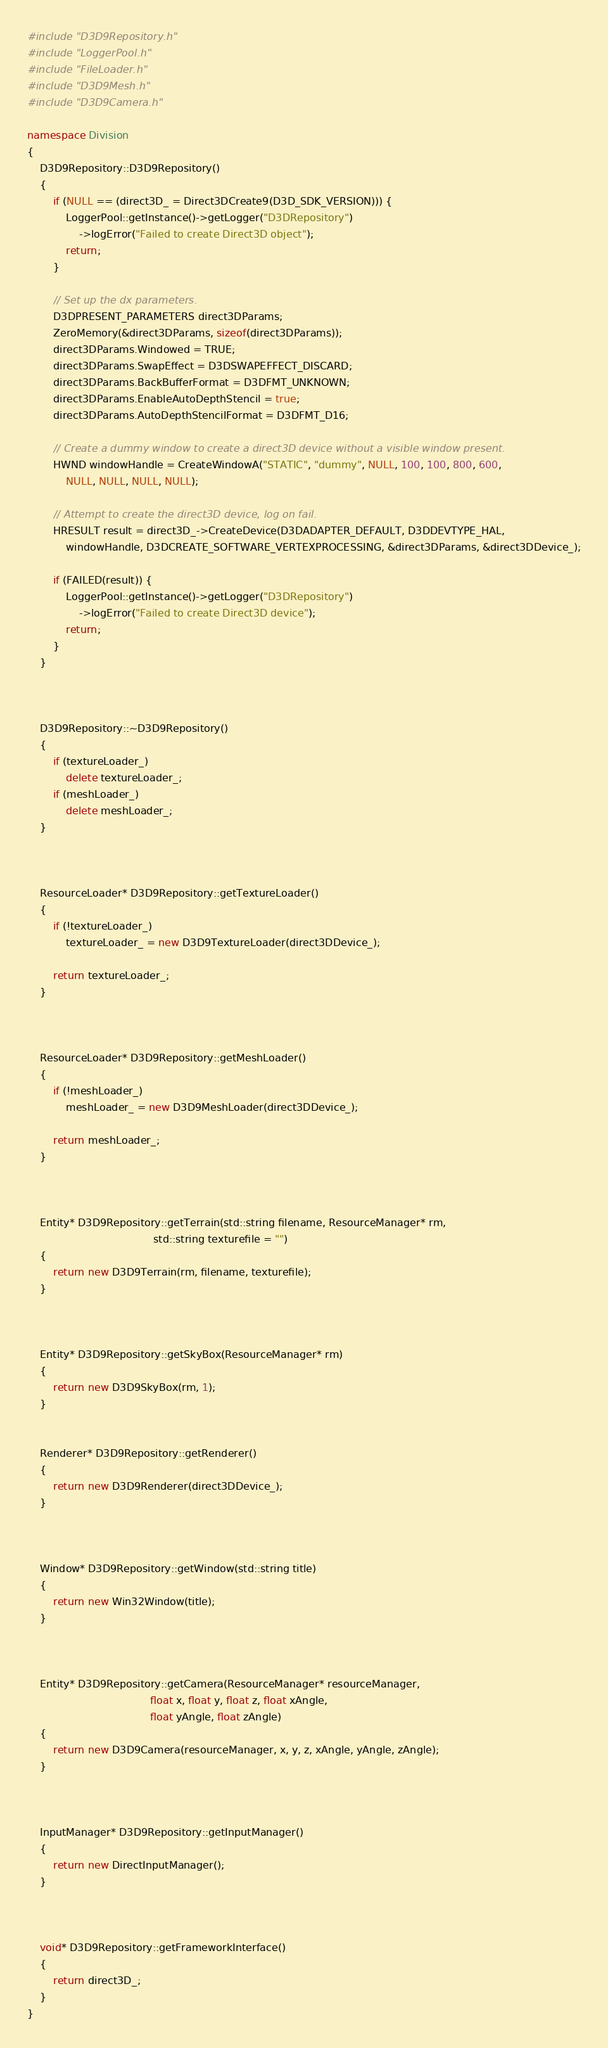<code> <loc_0><loc_0><loc_500><loc_500><_C++_>#include "D3D9Repository.h"
#include "LoggerPool.h"
#include "FileLoader.h"
#include "D3D9Mesh.h"
#include "D3D9Camera.h"

namespace Division
{
	D3D9Repository::D3D9Repository()
	{
		if (NULL == (direct3D_ = Direct3DCreate9(D3D_SDK_VERSION))) {
			LoggerPool::getInstance()->getLogger("D3DRepository")
				->logError("Failed to create Direct3D object");
			return;
		}

		// Set up the dx parameters.
		D3DPRESENT_PARAMETERS direct3DParams;
		ZeroMemory(&direct3DParams, sizeof(direct3DParams));
		direct3DParams.Windowed = TRUE;
		direct3DParams.SwapEffect = D3DSWAPEFFECT_DISCARD;
		direct3DParams.BackBufferFormat = D3DFMT_UNKNOWN;
		direct3DParams.EnableAutoDepthStencil = true;
		direct3DParams.AutoDepthStencilFormat = D3DFMT_D16;

		// Create a dummy window to create a direct3D device without a visible window present.
		HWND windowHandle = CreateWindowA("STATIC", "dummy", NULL, 100, 100, 800, 600,
			NULL, NULL, NULL, NULL);

		// Attempt to create the direct3D device, log on fail.
		HRESULT result = direct3D_->CreateDevice(D3DADAPTER_DEFAULT, D3DDEVTYPE_HAL,
			windowHandle, D3DCREATE_SOFTWARE_VERTEXPROCESSING, &direct3DParams, &direct3DDevice_);

		if (FAILED(result)) {
			LoggerPool::getInstance()->getLogger("D3DRepository")
				->logError("Failed to create Direct3D device");
			return;
		}
	}



	D3D9Repository::~D3D9Repository()
	{
		if (textureLoader_)
			delete textureLoader_;
		if (meshLoader_)
			delete meshLoader_;
	}



	ResourceLoader* D3D9Repository::getTextureLoader()
	{
		if (!textureLoader_)
			textureLoader_ = new D3D9TextureLoader(direct3DDevice_);
			
		return textureLoader_;
	}



	ResourceLoader* D3D9Repository::getMeshLoader()
	{
		if (!meshLoader_)
			meshLoader_ = new D3D9MeshLoader(direct3DDevice_);
		
		return meshLoader_;
	}



	Entity* D3D9Repository::getTerrain(std::string filename, ResourceManager* rm,
									   std::string texturefile = "")
	{
		return new D3D9Terrain(rm, filename, texturefile);
	}
	


	Entity* D3D9Repository::getSkyBox(ResourceManager* rm)
	{
		return new D3D9SkyBox(rm, 1);
	}


	Renderer* D3D9Repository::getRenderer()
	{
		return new D3D9Renderer(direct3DDevice_);
	}



	Window* D3D9Repository::getWindow(std::string title)
	{
		return new Win32Window(title);
	}



	Entity* D3D9Repository::getCamera(ResourceManager* resourceManager, 
									  float x, float y, float z, float xAngle,
									  float yAngle, float zAngle)
	{
		return new D3D9Camera(resourceManager, x, y, z, xAngle, yAngle, zAngle);
	}



	InputManager* D3D9Repository::getInputManager()
	{
		return new DirectInputManager();
	}
	


	void* D3D9Repository::getFrameworkInterface()
	{
		return direct3D_;
	}
}</code> 